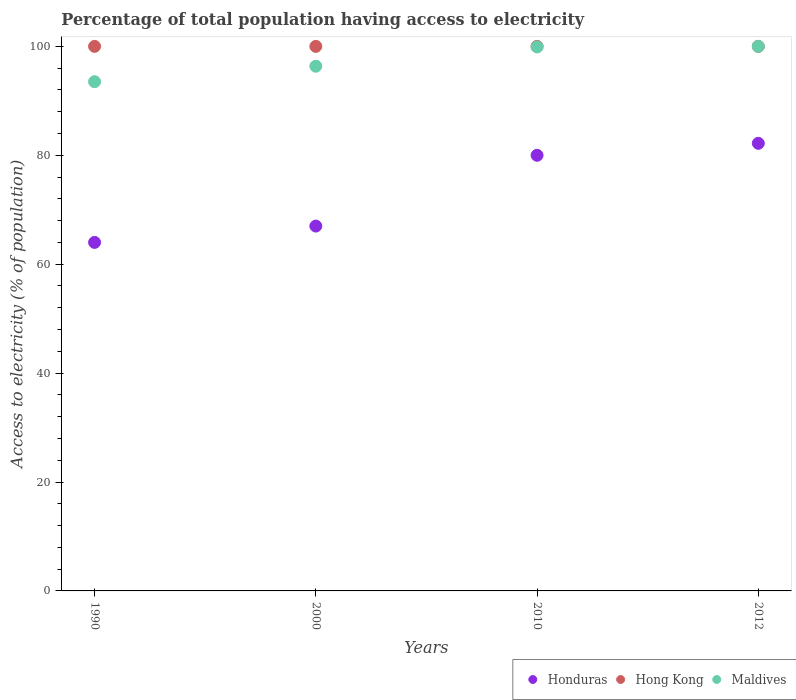Is the number of dotlines equal to the number of legend labels?
Ensure brevity in your answer.  Yes. What is the percentage of population that have access to electricity in Honduras in 2010?
Offer a very short reply. 80. Across all years, what is the maximum percentage of population that have access to electricity in Maldives?
Provide a short and direct response. 100. In which year was the percentage of population that have access to electricity in Honduras maximum?
Your response must be concise. 2012. What is the total percentage of population that have access to electricity in Hong Kong in the graph?
Your response must be concise. 400. What is the difference between the percentage of population that have access to electricity in Maldives in 2000 and that in 2012?
Your answer should be compact. -3.64. What is the difference between the percentage of population that have access to electricity in Hong Kong in 2000 and the percentage of population that have access to electricity in Honduras in 2012?
Your answer should be very brief. 17.8. What is the average percentage of population that have access to electricity in Honduras per year?
Make the answer very short. 73.3. In the year 2000, what is the difference between the percentage of population that have access to electricity in Hong Kong and percentage of population that have access to electricity in Maldives?
Make the answer very short. 3.64. What is the difference between the highest and the second highest percentage of population that have access to electricity in Hong Kong?
Make the answer very short. 0. What is the difference between the highest and the lowest percentage of population that have access to electricity in Maldives?
Your response must be concise. 6.48. Is it the case that in every year, the sum of the percentage of population that have access to electricity in Maldives and percentage of population that have access to electricity in Honduras  is greater than the percentage of population that have access to electricity in Hong Kong?
Offer a terse response. Yes. Does the percentage of population that have access to electricity in Maldives monotonically increase over the years?
Give a very brief answer. Yes. Is the percentage of population that have access to electricity in Maldives strictly less than the percentage of population that have access to electricity in Honduras over the years?
Your answer should be compact. No. Are the values on the major ticks of Y-axis written in scientific E-notation?
Your answer should be compact. No. Does the graph contain grids?
Keep it short and to the point. No. What is the title of the graph?
Your answer should be compact. Percentage of total population having access to electricity. What is the label or title of the Y-axis?
Keep it short and to the point. Access to electricity (% of population). What is the Access to electricity (% of population) in Maldives in 1990?
Your answer should be very brief. 93.52. What is the Access to electricity (% of population) in Maldives in 2000?
Keep it short and to the point. 96.36. What is the Access to electricity (% of population) in Honduras in 2010?
Your answer should be very brief. 80. What is the Access to electricity (% of population) in Maldives in 2010?
Keep it short and to the point. 99.9. What is the Access to electricity (% of population) in Honduras in 2012?
Give a very brief answer. 82.2. What is the Access to electricity (% of population) of Hong Kong in 2012?
Your answer should be compact. 100. What is the Access to electricity (% of population) in Maldives in 2012?
Your answer should be compact. 100. Across all years, what is the maximum Access to electricity (% of population) in Honduras?
Offer a very short reply. 82.2. Across all years, what is the maximum Access to electricity (% of population) of Hong Kong?
Your response must be concise. 100. Across all years, what is the minimum Access to electricity (% of population) in Honduras?
Your response must be concise. 64. Across all years, what is the minimum Access to electricity (% of population) in Maldives?
Give a very brief answer. 93.52. What is the total Access to electricity (% of population) in Honduras in the graph?
Make the answer very short. 293.2. What is the total Access to electricity (% of population) of Maldives in the graph?
Ensure brevity in your answer.  389.77. What is the difference between the Access to electricity (% of population) of Honduras in 1990 and that in 2000?
Your response must be concise. -3. What is the difference between the Access to electricity (% of population) of Maldives in 1990 and that in 2000?
Give a very brief answer. -2.84. What is the difference between the Access to electricity (% of population) of Honduras in 1990 and that in 2010?
Ensure brevity in your answer.  -16. What is the difference between the Access to electricity (% of population) of Hong Kong in 1990 and that in 2010?
Your answer should be very brief. 0. What is the difference between the Access to electricity (% of population) in Maldives in 1990 and that in 2010?
Your answer should be compact. -6.38. What is the difference between the Access to electricity (% of population) in Honduras in 1990 and that in 2012?
Ensure brevity in your answer.  -18.2. What is the difference between the Access to electricity (% of population) of Hong Kong in 1990 and that in 2012?
Your response must be concise. 0. What is the difference between the Access to electricity (% of population) of Maldives in 1990 and that in 2012?
Give a very brief answer. -6.48. What is the difference between the Access to electricity (% of population) in Honduras in 2000 and that in 2010?
Give a very brief answer. -13. What is the difference between the Access to electricity (% of population) in Hong Kong in 2000 and that in 2010?
Your response must be concise. 0. What is the difference between the Access to electricity (% of population) of Maldives in 2000 and that in 2010?
Your response must be concise. -3.54. What is the difference between the Access to electricity (% of population) in Honduras in 2000 and that in 2012?
Your response must be concise. -15.2. What is the difference between the Access to electricity (% of population) of Maldives in 2000 and that in 2012?
Your response must be concise. -3.64. What is the difference between the Access to electricity (% of population) in Honduras in 2010 and that in 2012?
Provide a short and direct response. -2.2. What is the difference between the Access to electricity (% of population) in Maldives in 2010 and that in 2012?
Offer a very short reply. -0.1. What is the difference between the Access to electricity (% of population) of Honduras in 1990 and the Access to electricity (% of population) of Hong Kong in 2000?
Your response must be concise. -36. What is the difference between the Access to electricity (% of population) of Honduras in 1990 and the Access to electricity (% of population) of Maldives in 2000?
Your answer should be very brief. -32.36. What is the difference between the Access to electricity (% of population) in Hong Kong in 1990 and the Access to electricity (% of population) in Maldives in 2000?
Your response must be concise. 3.64. What is the difference between the Access to electricity (% of population) in Honduras in 1990 and the Access to electricity (% of population) in Hong Kong in 2010?
Offer a terse response. -36. What is the difference between the Access to electricity (% of population) in Honduras in 1990 and the Access to electricity (% of population) in Maldives in 2010?
Your response must be concise. -35.9. What is the difference between the Access to electricity (% of population) of Hong Kong in 1990 and the Access to electricity (% of population) of Maldives in 2010?
Offer a very short reply. 0.1. What is the difference between the Access to electricity (% of population) in Honduras in 1990 and the Access to electricity (% of population) in Hong Kong in 2012?
Provide a succinct answer. -36. What is the difference between the Access to electricity (% of population) in Honduras in 1990 and the Access to electricity (% of population) in Maldives in 2012?
Provide a short and direct response. -36. What is the difference between the Access to electricity (% of population) in Hong Kong in 1990 and the Access to electricity (% of population) in Maldives in 2012?
Make the answer very short. 0. What is the difference between the Access to electricity (% of population) of Honduras in 2000 and the Access to electricity (% of population) of Hong Kong in 2010?
Give a very brief answer. -33. What is the difference between the Access to electricity (% of population) of Honduras in 2000 and the Access to electricity (% of population) of Maldives in 2010?
Your answer should be very brief. -32.9. What is the difference between the Access to electricity (% of population) of Hong Kong in 2000 and the Access to electricity (% of population) of Maldives in 2010?
Provide a short and direct response. 0.1. What is the difference between the Access to electricity (% of population) of Honduras in 2000 and the Access to electricity (% of population) of Hong Kong in 2012?
Offer a terse response. -33. What is the difference between the Access to electricity (% of population) in Honduras in 2000 and the Access to electricity (% of population) in Maldives in 2012?
Provide a short and direct response. -33. What is the difference between the Access to electricity (% of population) in Honduras in 2010 and the Access to electricity (% of population) in Hong Kong in 2012?
Your answer should be very brief. -20. What is the difference between the Access to electricity (% of population) in Honduras in 2010 and the Access to electricity (% of population) in Maldives in 2012?
Your response must be concise. -20. What is the difference between the Access to electricity (% of population) of Hong Kong in 2010 and the Access to electricity (% of population) of Maldives in 2012?
Ensure brevity in your answer.  0. What is the average Access to electricity (% of population) in Honduras per year?
Provide a short and direct response. 73.3. What is the average Access to electricity (% of population) in Hong Kong per year?
Provide a succinct answer. 100. What is the average Access to electricity (% of population) of Maldives per year?
Your response must be concise. 97.44. In the year 1990, what is the difference between the Access to electricity (% of population) of Honduras and Access to electricity (% of population) of Hong Kong?
Provide a short and direct response. -36. In the year 1990, what is the difference between the Access to electricity (% of population) of Honduras and Access to electricity (% of population) of Maldives?
Ensure brevity in your answer.  -29.52. In the year 1990, what is the difference between the Access to electricity (% of population) of Hong Kong and Access to electricity (% of population) of Maldives?
Your response must be concise. 6.48. In the year 2000, what is the difference between the Access to electricity (% of population) of Honduras and Access to electricity (% of population) of Hong Kong?
Give a very brief answer. -33. In the year 2000, what is the difference between the Access to electricity (% of population) of Honduras and Access to electricity (% of population) of Maldives?
Your response must be concise. -29.36. In the year 2000, what is the difference between the Access to electricity (% of population) in Hong Kong and Access to electricity (% of population) in Maldives?
Give a very brief answer. 3.64. In the year 2010, what is the difference between the Access to electricity (% of population) of Honduras and Access to electricity (% of population) of Hong Kong?
Provide a short and direct response. -20. In the year 2010, what is the difference between the Access to electricity (% of population) of Honduras and Access to electricity (% of population) of Maldives?
Provide a short and direct response. -19.9. In the year 2012, what is the difference between the Access to electricity (% of population) in Honduras and Access to electricity (% of population) in Hong Kong?
Ensure brevity in your answer.  -17.8. In the year 2012, what is the difference between the Access to electricity (% of population) of Honduras and Access to electricity (% of population) of Maldives?
Make the answer very short. -17.8. What is the ratio of the Access to electricity (% of population) of Honduras in 1990 to that in 2000?
Give a very brief answer. 0.96. What is the ratio of the Access to electricity (% of population) of Hong Kong in 1990 to that in 2000?
Give a very brief answer. 1. What is the ratio of the Access to electricity (% of population) in Maldives in 1990 to that in 2000?
Keep it short and to the point. 0.97. What is the ratio of the Access to electricity (% of population) of Hong Kong in 1990 to that in 2010?
Ensure brevity in your answer.  1. What is the ratio of the Access to electricity (% of population) in Maldives in 1990 to that in 2010?
Provide a short and direct response. 0.94. What is the ratio of the Access to electricity (% of population) in Honduras in 1990 to that in 2012?
Offer a terse response. 0.78. What is the ratio of the Access to electricity (% of population) in Maldives in 1990 to that in 2012?
Offer a very short reply. 0.94. What is the ratio of the Access to electricity (% of population) in Honduras in 2000 to that in 2010?
Offer a terse response. 0.84. What is the ratio of the Access to electricity (% of population) of Maldives in 2000 to that in 2010?
Your answer should be very brief. 0.96. What is the ratio of the Access to electricity (% of population) in Honduras in 2000 to that in 2012?
Keep it short and to the point. 0.82. What is the ratio of the Access to electricity (% of population) in Hong Kong in 2000 to that in 2012?
Offer a very short reply. 1. What is the ratio of the Access to electricity (% of population) of Maldives in 2000 to that in 2012?
Offer a terse response. 0.96. What is the ratio of the Access to electricity (% of population) in Honduras in 2010 to that in 2012?
Make the answer very short. 0.97. What is the difference between the highest and the second highest Access to electricity (% of population) in Honduras?
Offer a terse response. 2.2. What is the difference between the highest and the lowest Access to electricity (% of population) in Honduras?
Provide a succinct answer. 18.2. What is the difference between the highest and the lowest Access to electricity (% of population) of Hong Kong?
Provide a succinct answer. 0. What is the difference between the highest and the lowest Access to electricity (% of population) of Maldives?
Provide a succinct answer. 6.48. 